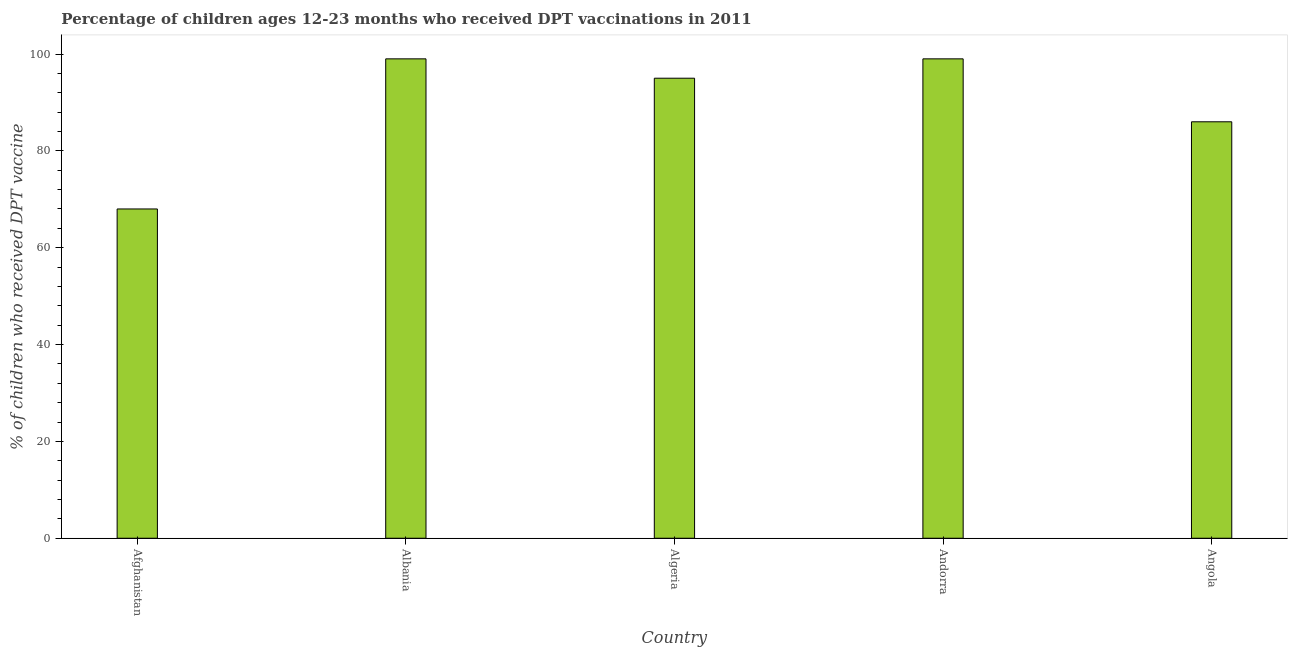Does the graph contain any zero values?
Keep it short and to the point. No. What is the title of the graph?
Your answer should be very brief. Percentage of children ages 12-23 months who received DPT vaccinations in 2011. What is the label or title of the Y-axis?
Keep it short and to the point. % of children who received DPT vaccine. Across all countries, what is the minimum percentage of children who received dpt vaccine?
Make the answer very short. 68. In which country was the percentage of children who received dpt vaccine maximum?
Give a very brief answer. Albania. In which country was the percentage of children who received dpt vaccine minimum?
Your response must be concise. Afghanistan. What is the sum of the percentage of children who received dpt vaccine?
Offer a very short reply. 447. What is the difference between the percentage of children who received dpt vaccine in Afghanistan and Albania?
Keep it short and to the point. -31. What is the average percentage of children who received dpt vaccine per country?
Make the answer very short. 89.4. What is the median percentage of children who received dpt vaccine?
Your answer should be very brief. 95. What is the ratio of the percentage of children who received dpt vaccine in Afghanistan to that in Andorra?
Your answer should be very brief. 0.69. Is the percentage of children who received dpt vaccine in Albania less than that in Algeria?
Provide a succinct answer. No. Is the difference between the percentage of children who received dpt vaccine in Afghanistan and Algeria greater than the difference between any two countries?
Keep it short and to the point. No. Is the sum of the percentage of children who received dpt vaccine in Afghanistan and Albania greater than the maximum percentage of children who received dpt vaccine across all countries?
Provide a succinct answer. Yes. In how many countries, is the percentage of children who received dpt vaccine greater than the average percentage of children who received dpt vaccine taken over all countries?
Provide a succinct answer. 3. Are all the bars in the graph horizontal?
Provide a succinct answer. No. What is the difference between two consecutive major ticks on the Y-axis?
Provide a short and direct response. 20. Are the values on the major ticks of Y-axis written in scientific E-notation?
Keep it short and to the point. No. What is the % of children who received DPT vaccine of Algeria?
Offer a very short reply. 95. What is the % of children who received DPT vaccine in Andorra?
Ensure brevity in your answer.  99. What is the difference between the % of children who received DPT vaccine in Afghanistan and Albania?
Offer a very short reply. -31. What is the difference between the % of children who received DPT vaccine in Afghanistan and Andorra?
Offer a very short reply. -31. What is the difference between the % of children who received DPT vaccine in Afghanistan and Angola?
Offer a very short reply. -18. What is the difference between the % of children who received DPT vaccine in Albania and Algeria?
Make the answer very short. 4. What is the difference between the % of children who received DPT vaccine in Albania and Andorra?
Give a very brief answer. 0. What is the ratio of the % of children who received DPT vaccine in Afghanistan to that in Albania?
Keep it short and to the point. 0.69. What is the ratio of the % of children who received DPT vaccine in Afghanistan to that in Algeria?
Your answer should be very brief. 0.72. What is the ratio of the % of children who received DPT vaccine in Afghanistan to that in Andorra?
Offer a terse response. 0.69. What is the ratio of the % of children who received DPT vaccine in Afghanistan to that in Angola?
Provide a short and direct response. 0.79. What is the ratio of the % of children who received DPT vaccine in Albania to that in Algeria?
Provide a short and direct response. 1.04. What is the ratio of the % of children who received DPT vaccine in Albania to that in Andorra?
Provide a succinct answer. 1. What is the ratio of the % of children who received DPT vaccine in Albania to that in Angola?
Make the answer very short. 1.15. What is the ratio of the % of children who received DPT vaccine in Algeria to that in Andorra?
Provide a short and direct response. 0.96. What is the ratio of the % of children who received DPT vaccine in Algeria to that in Angola?
Ensure brevity in your answer.  1.1. What is the ratio of the % of children who received DPT vaccine in Andorra to that in Angola?
Offer a terse response. 1.15. 